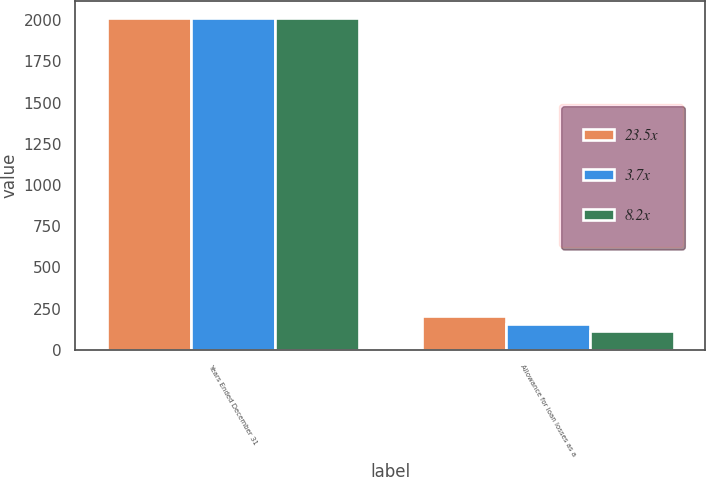<chart> <loc_0><loc_0><loc_500><loc_500><stacked_bar_chart><ecel><fcel>Years Ended December 31<fcel>Allowance for loan losses as a<nl><fcel>23.5x<fcel>2014<fcel>205<nl><fcel>3.7x<fcel>2013<fcel>160<nl><fcel>8.2x<fcel>2012<fcel>116<nl></chart> 